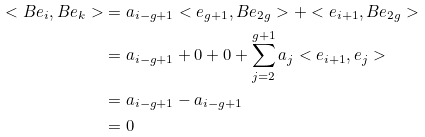<formula> <loc_0><loc_0><loc_500><loc_500>< B e _ { i } , B e _ { k } > & = a _ { i - g + 1 } < e _ { g + 1 } , B e _ { 2 g } > + < e _ { i + 1 } , B e _ { 2 g } > \\ & = a _ { i - g + 1 } + 0 + 0 + \sum _ { j = 2 } ^ { g + 1 } a _ { j } < e _ { i + 1 } , e _ { j } > \\ & = a _ { i - g + 1 } - a _ { i - g + 1 } \\ & = 0</formula> 